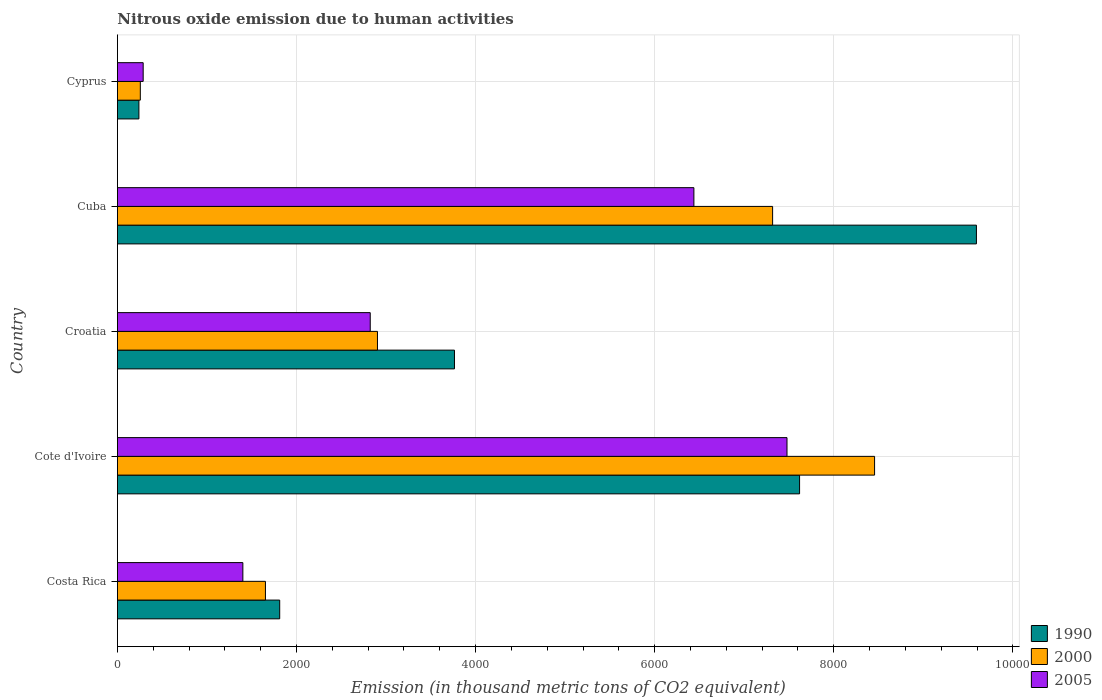How many different coloured bars are there?
Your response must be concise. 3. Are the number of bars per tick equal to the number of legend labels?
Provide a short and direct response. Yes. Are the number of bars on each tick of the Y-axis equal?
Give a very brief answer. Yes. How many bars are there on the 2nd tick from the bottom?
Make the answer very short. 3. What is the label of the 3rd group of bars from the top?
Offer a very short reply. Croatia. In how many cases, is the number of bars for a given country not equal to the number of legend labels?
Your answer should be very brief. 0. What is the amount of nitrous oxide emitted in 1990 in Cyprus?
Offer a terse response. 240.2. Across all countries, what is the maximum amount of nitrous oxide emitted in 2005?
Keep it short and to the point. 7477.7. Across all countries, what is the minimum amount of nitrous oxide emitted in 1990?
Keep it short and to the point. 240.2. In which country was the amount of nitrous oxide emitted in 1990 maximum?
Your response must be concise. Cuba. In which country was the amount of nitrous oxide emitted in 2000 minimum?
Your answer should be compact. Cyprus. What is the total amount of nitrous oxide emitted in 1990 in the graph?
Offer a terse response. 2.30e+04. What is the difference between the amount of nitrous oxide emitted in 2005 in Cote d'Ivoire and that in Cuba?
Provide a succinct answer. 1039.9. What is the difference between the amount of nitrous oxide emitted in 2000 in Cuba and the amount of nitrous oxide emitted in 1990 in Cyprus?
Provide a short and direct response. 7076.8. What is the average amount of nitrous oxide emitted in 2000 per country?
Ensure brevity in your answer.  4117.22. What is the difference between the amount of nitrous oxide emitted in 1990 and amount of nitrous oxide emitted in 2005 in Croatia?
Keep it short and to the point. 940.7. In how many countries, is the amount of nitrous oxide emitted in 2005 greater than 6000 thousand metric tons?
Give a very brief answer. 2. What is the ratio of the amount of nitrous oxide emitted in 2005 in Costa Rica to that in Croatia?
Offer a terse response. 0.5. Is the amount of nitrous oxide emitted in 1990 in Costa Rica less than that in Cuba?
Make the answer very short. Yes. Is the difference between the amount of nitrous oxide emitted in 1990 in Croatia and Cyprus greater than the difference between the amount of nitrous oxide emitted in 2005 in Croatia and Cyprus?
Make the answer very short. Yes. What is the difference between the highest and the second highest amount of nitrous oxide emitted in 2000?
Give a very brief answer. 1138.7. What is the difference between the highest and the lowest amount of nitrous oxide emitted in 1990?
Offer a very short reply. 9352.7. Is the sum of the amount of nitrous oxide emitted in 2000 in Cote d'Ivoire and Cyprus greater than the maximum amount of nitrous oxide emitted in 1990 across all countries?
Give a very brief answer. No. Are all the bars in the graph horizontal?
Ensure brevity in your answer.  Yes. What is the difference between two consecutive major ticks on the X-axis?
Your answer should be very brief. 2000. Does the graph contain any zero values?
Ensure brevity in your answer.  No. What is the title of the graph?
Ensure brevity in your answer.  Nitrous oxide emission due to human activities. What is the label or title of the X-axis?
Give a very brief answer. Emission (in thousand metric tons of CO2 equivalent). What is the label or title of the Y-axis?
Give a very brief answer. Country. What is the Emission (in thousand metric tons of CO2 equivalent) of 1990 in Costa Rica?
Your answer should be very brief. 1812.5. What is the Emission (in thousand metric tons of CO2 equivalent) of 2000 in Costa Rica?
Make the answer very short. 1653.2. What is the Emission (in thousand metric tons of CO2 equivalent) in 2005 in Costa Rica?
Provide a short and direct response. 1401. What is the Emission (in thousand metric tons of CO2 equivalent) in 1990 in Cote d'Ivoire?
Keep it short and to the point. 7618. What is the Emission (in thousand metric tons of CO2 equivalent) of 2000 in Cote d'Ivoire?
Provide a succinct answer. 8455.7. What is the Emission (in thousand metric tons of CO2 equivalent) of 2005 in Cote d'Ivoire?
Make the answer very short. 7477.7. What is the Emission (in thousand metric tons of CO2 equivalent) of 1990 in Croatia?
Provide a short and direct response. 3764.1. What is the Emission (in thousand metric tons of CO2 equivalent) in 2000 in Croatia?
Offer a very short reply. 2904.3. What is the Emission (in thousand metric tons of CO2 equivalent) in 2005 in Croatia?
Keep it short and to the point. 2823.4. What is the Emission (in thousand metric tons of CO2 equivalent) in 1990 in Cuba?
Offer a very short reply. 9592.9. What is the Emission (in thousand metric tons of CO2 equivalent) in 2000 in Cuba?
Your answer should be very brief. 7317. What is the Emission (in thousand metric tons of CO2 equivalent) of 2005 in Cuba?
Your response must be concise. 6437.8. What is the Emission (in thousand metric tons of CO2 equivalent) in 1990 in Cyprus?
Ensure brevity in your answer.  240.2. What is the Emission (in thousand metric tons of CO2 equivalent) of 2000 in Cyprus?
Your answer should be compact. 255.9. What is the Emission (in thousand metric tons of CO2 equivalent) of 2005 in Cyprus?
Provide a succinct answer. 287.8. Across all countries, what is the maximum Emission (in thousand metric tons of CO2 equivalent) in 1990?
Provide a short and direct response. 9592.9. Across all countries, what is the maximum Emission (in thousand metric tons of CO2 equivalent) of 2000?
Provide a succinct answer. 8455.7. Across all countries, what is the maximum Emission (in thousand metric tons of CO2 equivalent) in 2005?
Ensure brevity in your answer.  7477.7. Across all countries, what is the minimum Emission (in thousand metric tons of CO2 equivalent) of 1990?
Your response must be concise. 240.2. Across all countries, what is the minimum Emission (in thousand metric tons of CO2 equivalent) in 2000?
Your answer should be compact. 255.9. Across all countries, what is the minimum Emission (in thousand metric tons of CO2 equivalent) of 2005?
Offer a very short reply. 287.8. What is the total Emission (in thousand metric tons of CO2 equivalent) of 1990 in the graph?
Make the answer very short. 2.30e+04. What is the total Emission (in thousand metric tons of CO2 equivalent) in 2000 in the graph?
Keep it short and to the point. 2.06e+04. What is the total Emission (in thousand metric tons of CO2 equivalent) of 2005 in the graph?
Provide a short and direct response. 1.84e+04. What is the difference between the Emission (in thousand metric tons of CO2 equivalent) in 1990 in Costa Rica and that in Cote d'Ivoire?
Your answer should be compact. -5805.5. What is the difference between the Emission (in thousand metric tons of CO2 equivalent) in 2000 in Costa Rica and that in Cote d'Ivoire?
Make the answer very short. -6802.5. What is the difference between the Emission (in thousand metric tons of CO2 equivalent) of 2005 in Costa Rica and that in Cote d'Ivoire?
Offer a terse response. -6076.7. What is the difference between the Emission (in thousand metric tons of CO2 equivalent) of 1990 in Costa Rica and that in Croatia?
Provide a succinct answer. -1951.6. What is the difference between the Emission (in thousand metric tons of CO2 equivalent) of 2000 in Costa Rica and that in Croatia?
Provide a succinct answer. -1251.1. What is the difference between the Emission (in thousand metric tons of CO2 equivalent) in 2005 in Costa Rica and that in Croatia?
Provide a short and direct response. -1422.4. What is the difference between the Emission (in thousand metric tons of CO2 equivalent) of 1990 in Costa Rica and that in Cuba?
Your answer should be very brief. -7780.4. What is the difference between the Emission (in thousand metric tons of CO2 equivalent) of 2000 in Costa Rica and that in Cuba?
Offer a very short reply. -5663.8. What is the difference between the Emission (in thousand metric tons of CO2 equivalent) in 2005 in Costa Rica and that in Cuba?
Your answer should be compact. -5036.8. What is the difference between the Emission (in thousand metric tons of CO2 equivalent) in 1990 in Costa Rica and that in Cyprus?
Ensure brevity in your answer.  1572.3. What is the difference between the Emission (in thousand metric tons of CO2 equivalent) of 2000 in Costa Rica and that in Cyprus?
Your answer should be compact. 1397.3. What is the difference between the Emission (in thousand metric tons of CO2 equivalent) in 2005 in Costa Rica and that in Cyprus?
Provide a short and direct response. 1113.2. What is the difference between the Emission (in thousand metric tons of CO2 equivalent) of 1990 in Cote d'Ivoire and that in Croatia?
Ensure brevity in your answer.  3853.9. What is the difference between the Emission (in thousand metric tons of CO2 equivalent) of 2000 in Cote d'Ivoire and that in Croatia?
Your answer should be very brief. 5551.4. What is the difference between the Emission (in thousand metric tons of CO2 equivalent) of 2005 in Cote d'Ivoire and that in Croatia?
Keep it short and to the point. 4654.3. What is the difference between the Emission (in thousand metric tons of CO2 equivalent) in 1990 in Cote d'Ivoire and that in Cuba?
Offer a terse response. -1974.9. What is the difference between the Emission (in thousand metric tons of CO2 equivalent) of 2000 in Cote d'Ivoire and that in Cuba?
Provide a succinct answer. 1138.7. What is the difference between the Emission (in thousand metric tons of CO2 equivalent) of 2005 in Cote d'Ivoire and that in Cuba?
Your answer should be very brief. 1039.9. What is the difference between the Emission (in thousand metric tons of CO2 equivalent) of 1990 in Cote d'Ivoire and that in Cyprus?
Provide a succinct answer. 7377.8. What is the difference between the Emission (in thousand metric tons of CO2 equivalent) in 2000 in Cote d'Ivoire and that in Cyprus?
Offer a very short reply. 8199.8. What is the difference between the Emission (in thousand metric tons of CO2 equivalent) of 2005 in Cote d'Ivoire and that in Cyprus?
Your answer should be very brief. 7189.9. What is the difference between the Emission (in thousand metric tons of CO2 equivalent) in 1990 in Croatia and that in Cuba?
Give a very brief answer. -5828.8. What is the difference between the Emission (in thousand metric tons of CO2 equivalent) of 2000 in Croatia and that in Cuba?
Provide a succinct answer. -4412.7. What is the difference between the Emission (in thousand metric tons of CO2 equivalent) of 2005 in Croatia and that in Cuba?
Provide a short and direct response. -3614.4. What is the difference between the Emission (in thousand metric tons of CO2 equivalent) of 1990 in Croatia and that in Cyprus?
Give a very brief answer. 3523.9. What is the difference between the Emission (in thousand metric tons of CO2 equivalent) in 2000 in Croatia and that in Cyprus?
Your response must be concise. 2648.4. What is the difference between the Emission (in thousand metric tons of CO2 equivalent) of 2005 in Croatia and that in Cyprus?
Your answer should be very brief. 2535.6. What is the difference between the Emission (in thousand metric tons of CO2 equivalent) of 1990 in Cuba and that in Cyprus?
Your answer should be very brief. 9352.7. What is the difference between the Emission (in thousand metric tons of CO2 equivalent) of 2000 in Cuba and that in Cyprus?
Your answer should be very brief. 7061.1. What is the difference between the Emission (in thousand metric tons of CO2 equivalent) in 2005 in Cuba and that in Cyprus?
Ensure brevity in your answer.  6150. What is the difference between the Emission (in thousand metric tons of CO2 equivalent) in 1990 in Costa Rica and the Emission (in thousand metric tons of CO2 equivalent) in 2000 in Cote d'Ivoire?
Make the answer very short. -6643.2. What is the difference between the Emission (in thousand metric tons of CO2 equivalent) in 1990 in Costa Rica and the Emission (in thousand metric tons of CO2 equivalent) in 2005 in Cote d'Ivoire?
Offer a very short reply. -5665.2. What is the difference between the Emission (in thousand metric tons of CO2 equivalent) of 2000 in Costa Rica and the Emission (in thousand metric tons of CO2 equivalent) of 2005 in Cote d'Ivoire?
Offer a very short reply. -5824.5. What is the difference between the Emission (in thousand metric tons of CO2 equivalent) of 1990 in Costa Rica and the Emission (in thousand metric tons of CO2 equivalent) of 2000 in Croatia?
Keep it short and to the point. -1091.8. What is the difference between the Emission (in thousand metric tons of CO2 equivalent) of 1990 in Costa Rica and the Emission (in thousand metric tons of CO2 equivalent) of 2005 in Croatia?
Keep it short and to the point. -1010.9. What is the difference between the Emission (in thousand metric tons of CO2 equivalent) of 2000 in Costa Rica and the Emission (in thousand metric tons of CO2 equivalent) of 2005 in Croatia?
Provide a short and direct response. -1170.2. What is the difference between the Emission (in thousand metric tons of CO2 equivalent) of 1990 in Costa Rica and the Emission (in thousand metric tons of CO2 equivalent) of 2000 in Cuba?
Your answer should be compact. -5504.5. What is the difference between the Emission (in thousand metric tons of CO2 equivalent) in 1990 in Costa Rica and the Emission (in thousand metric tons of CO2 equivalent) in 2005 in Cuba?
Keep it short and to the point. -4625.3. What is the difference between the Emission (in thousand metric tons of CO2 equivalent) in 2000 in Costa Rica and the Emission (in thousand metric tons of CO2 equivalent) in 2005 in Cuba?
Give a very brief answer. -4784.6. What is the difference between the Emission (in thousand metric tons of CO2 equivalent) in 1990 in Costa Rica and the Emission (in thousand metric tons of CO2 equivalent) in 2000 in Cyprus?
Provide a succinct answer. 1556.6. What is the difference between the Emission (in thousand metric tons of CO2 equivalent) of 1990 in Costa Rica and the Emission (in thousand metric tons of CO2 equivalent) of 2005 in Cyprus?
Make the answer very short. 1524.7. What is the difference between the Emission (in thousand metric tons of CO2 equivalent) in 2000 in Costa Rica and the Emission (in thousand metric tons of CO2 equivalent) in 2005 in Cyprus?
Your answer should be compact. 1365.4. What is the difference between the Emission (in thousand metric tons of CO2 equivalent) in 1990 in Cote d'Ivoire and the Emission (in thousand metric tons of CO2 equivalent) in 2000 in Croatia?
Offer a terse response. 4713.7. What is the difference between the Emission (in thousand metric tons of CO2 equivalent) in 1990 in Cote d'Ivoire and the Emission (in thousand metric tons of CO2 equivalent) in 2005 in Croatia?
Your answer should be compact. 4794.6. What is the difference between the Emission (in thousand metric tons of CO2 equivalent) of 2000 in Cote d'Ivoire and the Emission (in thousand metric tons of CO2 equivalent) of 2005 in Croatia?
Ensure brevity in your answer.  5632.3. What is the difference between the Emission (in thousand metric tons of CO2 equivalent) in 1990 in Cote d'Ivoire and the Emission (in thousand metric tons of CO2 equivalent) in 2000 in Cuba?
Offer a terse response. 301. What is the difference between the Emission (in thousand metric tons of CO2 equivalent) of 1990 in Cote d'Ivoire and the Emission (in thousand metric tons of CO2 equivalent) of 2005 in Cuba?
Your answer should be very brief. 1180.2. What is the difference between the Emission (in thousand metric tons of CO2 equivalent) in 2000 in Cote d'Ivoire and the Emission (in thousand metric tons of CO2 equivalent) in 2005 in Cuba?
Keep it short and to the point. 2017.9. What is the difference between the Emission (in thousand metric tons of CO2 equivalent) of 1990 in Cote d'Ivoire and the Emission (in thousand metric tons of CO2 equivalent) of 2000 in Cyprus?
Your response must be concise. 7362.1. What is the difference between the Emission (in thousand metric tons of CO2 equivalent) in 1990 in Cote d'Ivoire and the Emission (in thousand metric tons of CO2 equivalent) in 2005 in Cyprus?
Offer a very short reply. 7330.2. What is the difference between the Emission (in thousand metric tons of CO2 equivalent) in 2000 in Cote d'Ivoire and the Emission (in thousand metric tons of CO2 equivalent) in 2005 in Cyprus?
Offer a very short reply. 8167.9. What is the difference between the Emission (in thousand metric tons of CO2 equivalent) in 1990 in Croatia and the Emission (in thousand metric tons of CO2 equivalent) in 2000 in Cuba?
Your response must be concise. -3552.9. What is the difference between the Emission (in thousand metric tons of CO2 equivalent) in 1990 in Croatia and the Emission (in thousand metric tons of CO2 equivalent) in 2005 in Cuba?
Provide a short and direct response. -2673.7. What is the difference between the Emission (in thousand metric tons of CO2 equivalent) in 2000 in Croatia and the Emission (in thousand metric tons of CO2 equivalent) in 2005 in Cuba?
Ensure brevity in your answer.  -3533.5. What is the difference between the Emission (in thousand metric tons of CO2 equivalent) in 1990 in Croatia and the Emission (in thousand metric tons of CO2 equivalent) in 2000 in Cyprus?
Keep it short and to the point. 3508.2. What is the difference between the Emission (in thousand metric tons of CO2 equivalent) of 1990 in Croatia and the Emission (in thousand metric tons of CO2 equivalent) of 2005 in Cyprus?
Provide a succinct answer. 3476.3. What is the difference between the Emission (in thousand metric tons of CO2 equivalent) of 2000 in Croatia and the Emission (in thousand metric tons of CO2 equivalent) of 2005 in Cyprus?
Provide a short and direct response. 2616.5. What is the difference between the Emission (in thousand metric tons of CO2 equivalent) in 1990 in Cuba and the Emission (in thousand metric tons of CO2 equivalent) in 2000 in Cyprus?
Give a very brief answer. 9337. What is the difference between the Emission (in thousand metric tons of CO2 equivalent) in 1990 in Cuba and the Emission (in thousand metric tons of CO2 equivalent) in 2005 in Cyprus?
Offer a very short reply. 9305.1. What is the difference between the Emission (in thousand metric tons of CO2 equivalent) of 2000 in Cuba and the Emission (in thousand metric tons of CO2 equivalent) of 2005 in Cyprus?
Ensure brevity in your answer.  7029.2. What is the average Emission (in thousand metric tons of CO2 equivalent) of 1990 per country?
Give a very brief answer. 4605.54. What is the average Emission (in thousand metric tons of CO2 equivalent) of 2000 per country?
Give a very brief answer. 4117.22. What is the average Emission (in thousand metric tons of CO2 equivalent) in 2005 per country?
Your answer should be compact. 3685.54. What is the difference between the Emission (in thousand metric tons of CO2 equivalent) in 1990 and Emission (in thousand metric tons of CO2 equivalent) in 2000 in Costa Rica?
Provide a short and direct response. 159.3. What is the difference between the Emission (in thousand metric tons of CO2 equivalent) in 1990 and Emission (in thousand metric tons of CO2 equivalent) in 2005 in Costa Rica?
Provide a succinct answer. 411.5. What is the difference between the Emission (in thousand metric tons of CO2 equivalent) of 2000 and Emission (in thousand metric tons of CO2 equivalent) of 2005 in Costa Rica?
Keep it short and to the point. 252.2. What is the difference between the Emission (in thousand metric tons of CO2 equivalent) of 1990 and Emission (in thousand metric tons of CO2 equivalent) of 2000 in Cote d'Ivoire?
Offer a very short reply. -837.7. What is the difference between the Emission (in thousand metric tons of CO2 equivalent) of 1990 and Emission (in thousand metric tons of CO2 equivalent) of 2005 in Cote d'Ivoire?
Your response must be concise. 140.3. What is the difference between the Emission (in thousand metric tons of CO2 equivalent) in 2000 and Emission (in thousand metric tons of CO2 equivalent) in 2005 in Cote d'Ivoire?
Your answer should be compact. 978. What is the difference between the Emission (in thousand metric tons of CO2 equivalent) of 1990 and Emission (in thousand metric tons of CO2 equivalent) of 2000 in Croatia?
Your response must be concise. 859.8. What is the difference between the Emission (in thousand metric tons of CO2 equivalent) in 1990 and Emission (in thousand metric tons of CO2 equivalent) in 2005 in Croatia?
Your answer should be compact. 940.7. What is the difference between the Emission (in thousand metric tons of CO2 equivalent) in 2000 and Emission (in thousand metric tons of CO2 equivalent) in 2005 in Croatia?
Offer a very short reply. 80.9. What is the difference between the Emission (in thousand metric tons of CO2 equivalent) of 1990 and Emission (in thousand metric tons of CO2 equivalent) of 2000 in Cuba?
Offer a very short reply. 2275.9. What is the difference between the Emission (in thousand metric tons of CO2 equivalent) in 1990 and Emission (in thousand metric tons of CO2 equivalent) in 2005 in Cuba?
Your answer should be compact. 3155.1. What is the difference between the Emission (in thousand metric tons of CO2 equivalent) in 2000 and Emission (in thousand metric tons of CO2 equivalent) in 2005 in Cuba?
Your answer should be compact. 879.2. What is the difference between the Emission (in thousand metric tons of CO2 equivalent) of 1990 and Emission (in thousand metric tons of CO2 equivalent) of 2000 in Cyprus?
Make the answer very short. -15.7. What is the difference between the Emission (in thousand metric tons of CO2 equivalent) of 1990 and Emission (in thousand metric tons of CO2 equivalent) of 2005 in Cyprus?
Your answer should be very brief. -47.6. What is the difference between the Emission (in thousand metric tons of CO2 equivalent) of 2000 and Emission (in thousand metric tons of CO2 equivalent) of 2005 in Cyprus?
Provide a short and direct response. -31.9. What is the ratio of the Emission (in thousand metric tons of CO2 equivalent) of 1990 in Costa Rica to that in Cote d'Ivoire?
Provide a succinct answer. 0.24. What is the ratio of the Emission (in thousand metric tons of CO2 equivalent) in 2000 in Costa Rica to that in Cote d'Ivoire?
Ensure brevity in your answer.  0.2. What is the ratio of the Emission (in thousand metric tons of CO2 equivalent) of 2005 in Costa Rica to that in Cote d'Ivoire?
Provide a short and direct response. 0.19. What is the ratio of the Emission (in thousand metric tons of CO2 equivalent) in 1990 in Costa Rica to that in Croatia?
Offer a terse response. 0.48. What is the ratio of the Emission (in thousand metric tons of CO2 equivalent) in 2000 in Costa Rica to that in Croatia?
Your answer should be very brief. 0.57. What is the ratio of the Emission (in thousand metric tons of CO2 equivalent) in 2005 in Costa Rica to that in Croatia?
Keep it short and to the point. 0.5. What is the ratio of the Emission (in thousand metric tons of CO2 equivalent) of 1990 in Costa Rica to that in Cuba?
Make the answer very short. 0.19. What is the ratio of the Emission (in thousand metric tons of CO2 equivalent) in 2000 in Costa Rica to that in Cuba?
Offer a terse response. 0.23. What is the ratio of the Emission (in thousand metric tons of CO2 equivalent) in 2005 in Costa Rica to that in Cuba?
Your response must be concise. 0.22. What is the ratio of the Emission (in thousand metric tons of CO2 equivalent) of 1990 in Costa Rica to that in Cyprus?
Give a very brief answer. 7.55. What is the ratio of the Emission (in thousand metric tons of CO2 equivalent) of 2000 in Costa Rica to that in Cyprus?
Make the answer very short. 6.46. What is the ratio of the Emission (in thousand metric tons of CO2 equivalent) in 2005 in Costa Rica to that in Cyprus?
Offer a very short reply. 4.87. What is the ratio of the Emission (in thousand metric tons of CO2 equivalent) of 1990 in Cote d'Ivoire to that in Croatia?
Provide a succinct answer. 2.02. What is the ratio of the Emission (in thousand metric tons of CO2 equivalent) of 2000 in Cote d'Ivoire to that in Croatia?
Your response must be concise. 2.91. What is the ratio of the Emission (in thousand metric tons of CO2 equivalent) of 2005 in Cote d'Ivoire to that in Croatia?
Keep it short and to the point. 2.65. What is the ratio of the Emission (in thousand metric tons of CO2 equivalent) in 1990 in Cote d'Ivoire to that in Cuba?
Ensure brevity in your answer.  0.79. What is the ratio of the Emission (in thousand metric tons of CO2 equivalent) in 2000 in Cote d'Ivoire to that in Cuba?
Your answer should be compact. 1.16. What is the ratio of the Emission (in thousand metric tons of CO2 equivalent) of 2005 in Cote d'Ivoire to that in Cuba?
Your answer should be very brief. 1.16. What is the ratio of the Emission (in thousand metric tons of CO2 equivalent) of 1990 in Cote d'Ivoire to that in Cyprus?
Give a very brief answer. 31.72. What is the ratio of the Emission (in thousand metric tons of CO2 equivalent) of 2000 in Cote d'Ivoire to that in Cyprus?
Ensure brevity in your answer.  33.04. What is the ratio of the Emission (in thousand metric tons of CO2 equivalent) in 2005 in Cote d'Ivoire to that in Cyprus?
Keep it short and to the point. 25.98. What is the ratio of the Emission (in thousand metric tons of CO2 equivalent) of 1990 in Croatia to that in Cuba?
Offer a terse response. 0.39. What is the ratio of the Emission (in thousand metric tons of CO2 equivalent) of 2000 in Croatia to that in Cuba?
Your response must be concise. 0.4. What is the ratio of the Emission (in thousand metric tons of CO2 equivalent) in 2005 in Croatia to that in Cuba?
Your response must be concise. 0.44. What is the ratio of the Emission (in thousand metric tons of CO2 equivalent) of 1990 in Croatia to that in Cyprus?
Make the answer very short. 15.67. What is the ratio of the Emission (in thousand metric tons of CO2 equivalent) in 2000 in Croatia to that in Cyprus?
Provide a succinct answer. 11.35. What is the ratio of the Emission (in thousand metric tons of CO2 equivalent) of 2005 in Croatia to that in Cyprus?
Your answer should be very brief. 9.81. What is the ratio of the Emission (in thousand metric tons of CO2 equivalent) of 1990 in Cuba to that in Cyprus?
Offer a terse response. 39.94. What is the ratio of the Emission (in thousand metric tons of CO2 equivalent) of 2000 in Cuba to that in Cyprus?
Your answer should be very brief. 28.59. What is the ratio of the Emission (in thousand metric tons of CO2 equivalent) of 2005 in Cuba to that in Cyprus?
Your response must be concise. 22.37. What is the difference between the highest and the second highest Emission (in thousand metric tons of CO2 equivalent) of 1990?
Ensure brevity in your answer.  1974.9. What is the difference between the highest and the second highest Emission (in thousand metric tons of CO2 equivalent) of 2000?
Your response must be concise. 1138.7. What is the difference between the highest and the second highest Emission (in thousand metric tons of CO2 equivalent) of 2005?
Make the answer very short. 1039.9. What is the difference between the highest and the lowest Emission (in thousand metric tons of CO2 equivalent) in 1990?
Offer a terse response. 9352.7. What is the difference between the highest and the lowest Emission (in thousand metric tons of CO2 equivalent) of 2000?
Provide a succinct answer. 8199.8. What is the difference between the highest and the lowest Emission (in thousand metric tons of CO2 equivalent) in 2005?
Make the answer very short. 7189.9. 